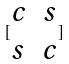<formula> <loc_0><loc_0><loc_500><loc_500>[ \begin{matrix} c & s \\ s & c \end{matrix} ]</formula> 